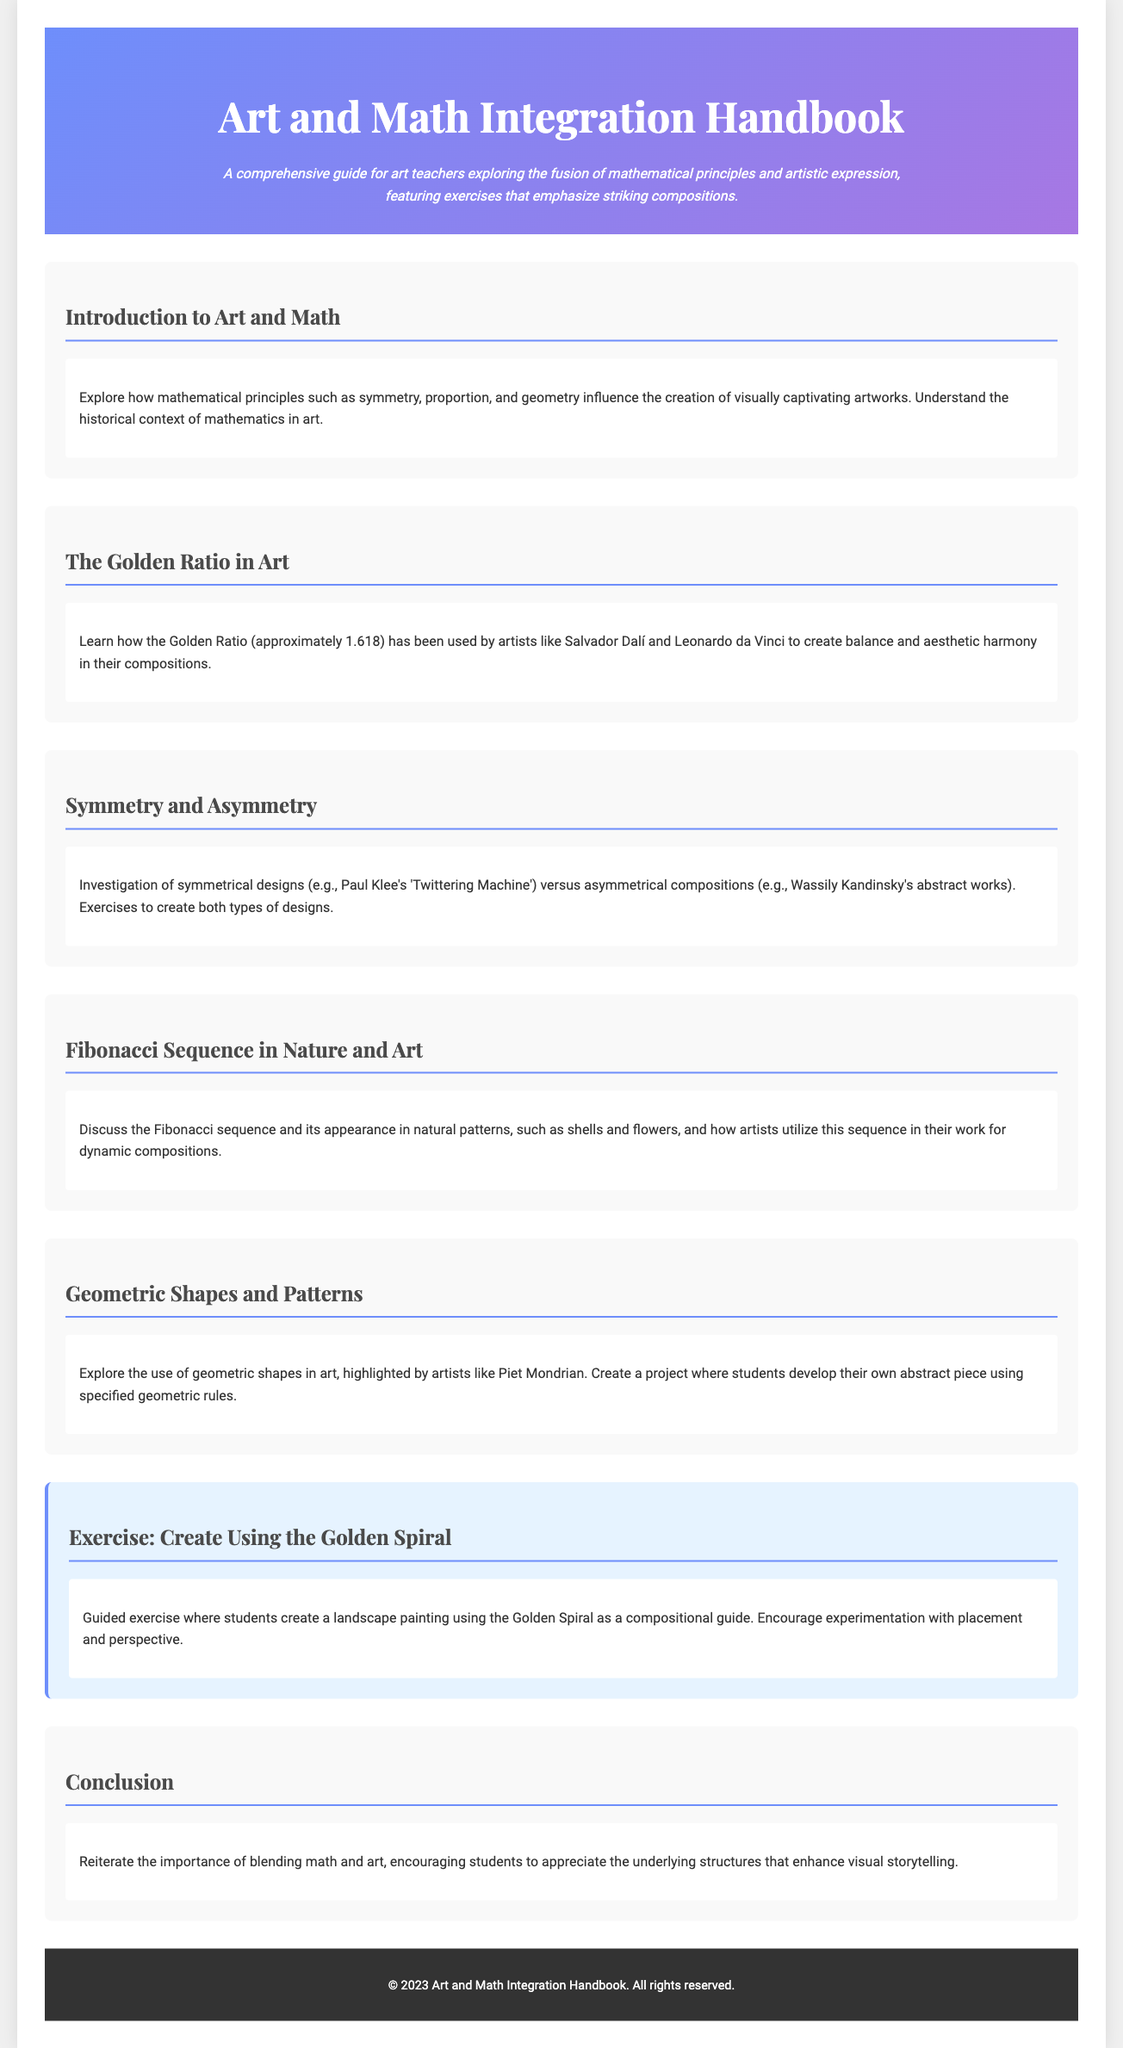What is the title of the handbook? The title appears in the header section of the document.
Answer: Art and Math Integration Handbook What principle is approximately 1.618? This principle is discussed in the section about art and mathematical concepts.
Answer: Golden Ratio Which artist is associated with symmetrical designs? The document references specific artworks to illustrate concepts of symmetry.
Answer: Paul Klee What sequence is discussed in relation to natural patterns? The sequence related to both nature and art is mentioned in its own section.
Answer: Fibonacci Sequence In which year was this handbook published? The copyright information at the bottom of the document provides the publication year.
Answer: 2023 What type of exercise is included that uses the Golden Spiral? The exercise described guides students to create a specific type of artwork.
Answer: Landscape painting What geometric influence is mentioned alongside Piet Mondrian? The document details a common mathematical shape used in various artworks.
Answer: Geometric shapes Which section discusses asymmetrical compositions? The content explores differences in design styles and artistic approaches.
Answer: Symmetry and Asymmetry What is one goal emphasized in the conclusion of the handbook? The conclusion reiterates a key takeaway from the document regarding the relationship between art and math.
Answer: Appreciation 